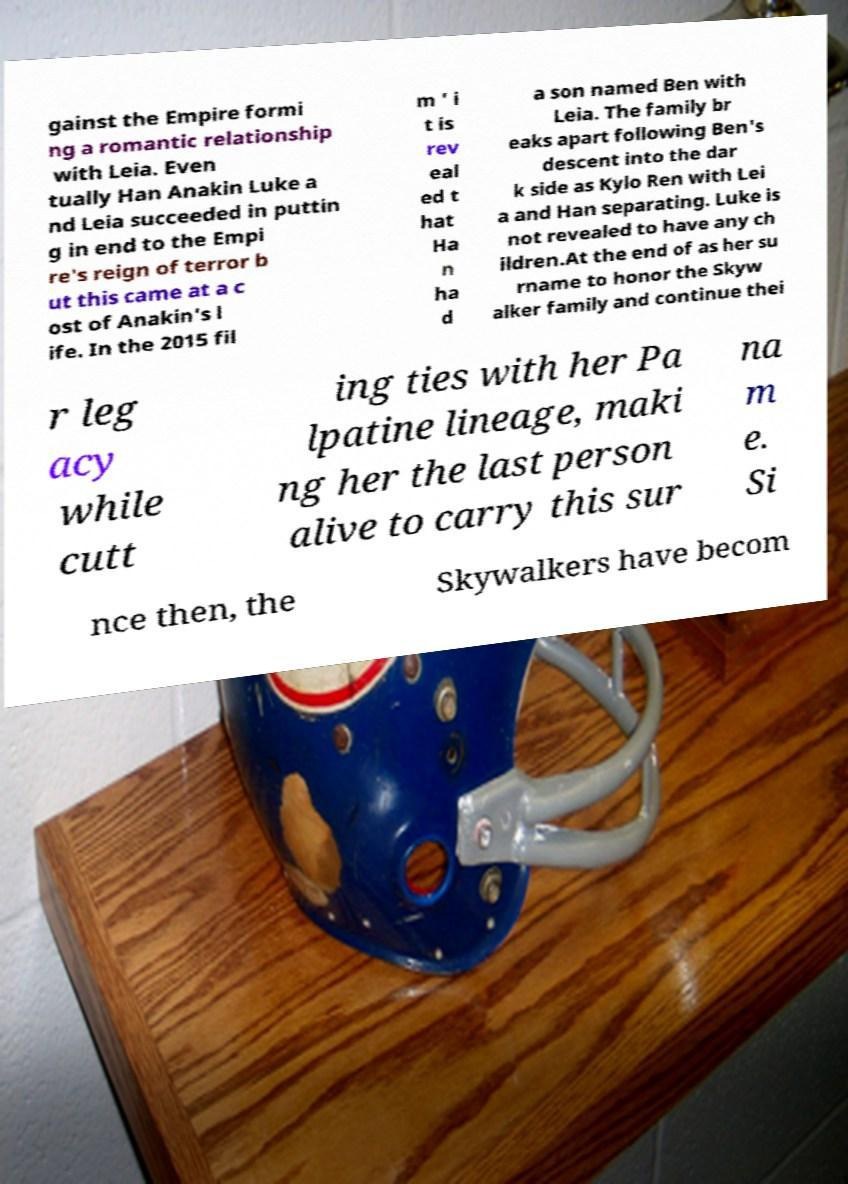Can you read and provide the text displayed in the image?This photo seems to have some interesting text. Can you extract and type it out for me? gainst the Empire formi ng a romantic relationship with Leia. Even tually Han Anakin Luke a nd Leia succeeded in puttin g in end to the Empi re's reign of terror b ut this came at a c ost of Anakin's l ife. In the 2015 fil m ' i t is rev eal ed t hat Ha n ha d a son named Ben with Leia. The family br eaks apart following Ben's descent into the dar k side as Kylo Ren with Lei a and Han separating. Luke is not revealed to have any ch ildren.At the end of as her su rname to honor the Skyw alker family and continue thei r leg acy while cutt ing ties with her Pa lpatine lineage, maki ng her the last person alive to carry this sur na m e. Si nce then, the Skywalkers have becom 